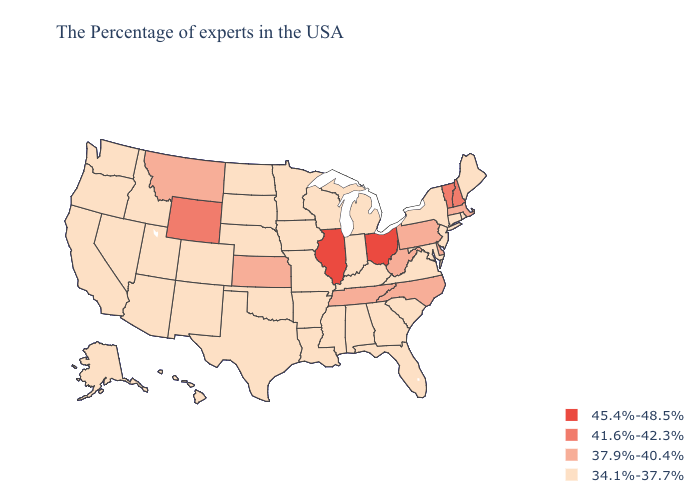Does Alabama have a higher value than North Carolina?
Short answer required. No. Name the states that have a value in the range 41.6%-42.3%?
Concise answer only. New Hampshire, Vermont, Wyoming. Does Tennessee have the lowest value in the South?
Be succinct. No. Name the states that have a value in the range 37.9%-40.4%?
Quick response, please. Massachusetts, Delaware, Pennsylvania, North Carolina, West Virginia, Tennessee, Kansas, Montana. Name the states that have a value in the range 34.1%-37.7%?
Give a very brief answer. Maine, Rhode Island, Connecticut, New York, New Jersey, Maryland, Virginia, South Carolina, Florida, Georgia, Michigan, Kentucky, Indiana, Alabama, Wisconsin, Mississippi, Louisiana, Missouri, Arkansas, Minnesota, Iowa, Nebraska, Oklahoma, Texas, South Dakota, North Dakota, Colorado, New Mexico, Utah, Arizona, Idaho, Nevada, California, Washington, Oregon, Alaska, Hawaii. Does the map have missing data?
Answer briefly. No. Is the legend a continuous bar?
Keep it brief. No. Which states hav the highest value in the MidWest?
Concise answer only. Ohio, Illinois. Name the states that have a value in the range 45.4%-48.5%?
Concise answer only. Ohio, Illinois. Name the states that have a value in the range 45.4%-48.5%?
Write a very short answer. Ohio, Illinois. Name the states that have a value in the range 45.4%-48.5%?
Be succinct. Ohio, Illinois. Among the states that border Rhode Island , which have the highest value?
Be succinct. Massachusetts. Among the states that border Kentucky , which have the highest value?
Quick response, please. Ohio, Illinois. Does the first symbol in the legend represent the smallest category?
Keep it brief. No. 